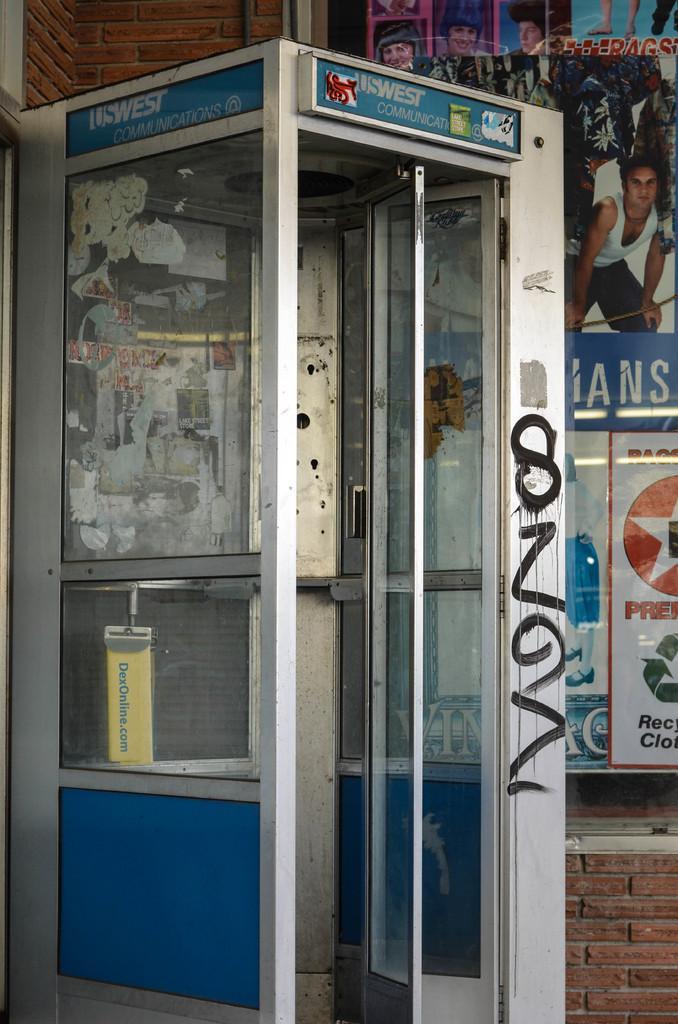Can you describe this image briefly? The picture consists of a small room with glass windows and door. On the right there are posters. On the left and at the bottom it is brick wall. 